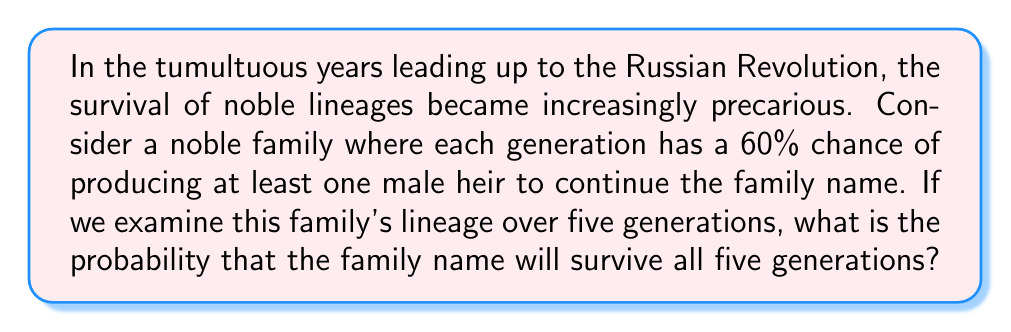What is the answer to this math problem? To solve this problem, we need to consider the probability of success (producing a male heir) in each generation and calculate the probability of this occurring in all five generations.

1. Let's define our events:
   $S_i$ = Success in generation $i$ (producing at least one male heir)
   $P(S_i) = 0.60$ for each generation

2. For the family name to survive all five generations, we need success in each generation. This is equivalent to the intersection of all five success events:

   $P(\text{survival}) = P(S_1 \cap S_2 \cap S_3 \cap S_4 \cap S_5)$

3. Since the events are independent (the success in one generation doesn't affect the probability in another), we can multiply the individual probabilities:

   $P(\text{survival}) = P(S_1) \cdot P(S_2) \cdot P(S_3) \cdot P(S_4) \cdot P(S_5)$

4. Substituting the given probability:

   $P(\text{survival}) = 0.60 \cdot 0.60 \cdot 0.60 \cdot 0.60 \cdot 0.60$

5. Simplifying:

   $P(\text{survival}) = (0.60)^5 = 0.07776$

6. Converting to a percentage:

   $0.07776 \cdot 100\% = 7.776\%$

Thus, the probability that the noble family's name will survive all five generations is approximately 7.776%.
Answer: $7.776\%$ or $0.07776$ 